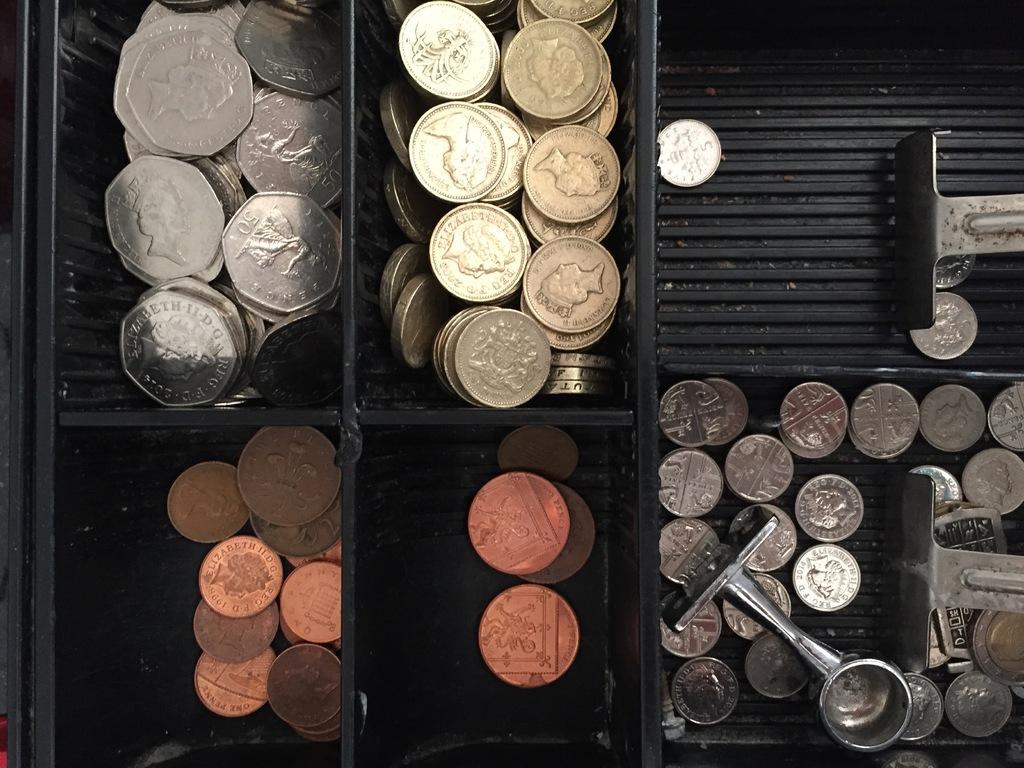What is the number value on the coins in the upper left bin?
Offer a very short reply. 50. 